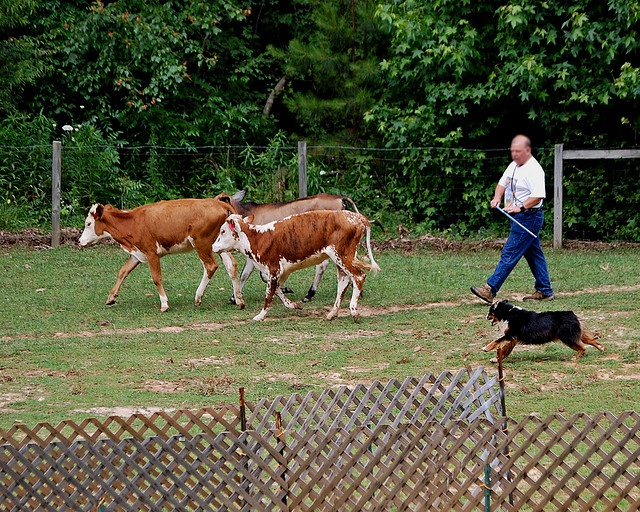Describe the objects in this image and their specific colors. I can see cow in black, maroon, brown, and lightgray tones, cow in black, brown, maroon, salmon, and tan tones, people in black, white, navy, and lightpink tones, dog in black, maroon, gray, and darkgray tones, and cow in black, darkgray, brown, and tan tones in this image. 